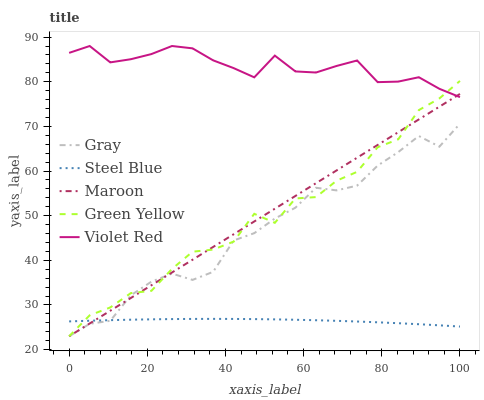Does Steel Blue have the minimum area under the curve?
Answer yes or no. Yes. Does Violet Red have the maximum area under the curve?
Answer yes or no. Yes. Does Green Yellow have the minimum area under the curve?
Answer yes or no. No. Does Green Yellow have the maximum area under the curve?
Answer yes or no. No. Is Maroon the smoothest?
Answer yes or no. Yes. Is Green Yellow the roughest?
Answer yes or no. Yes. Is Violet Red the smoothest?
Answer yes or no. No. Is Violet Red the roughest?
Answer yes or no. No. Does Violet Red have the lowest value?
Answer yes or no. No. Does Violet Red have the highest value?
Answer yes or no. Yes. Does Green Yellow have the highest value?
Answer yes or no. No. Is Gray less than Violet Red?
Answer yes or no. Yes. Is Violet Red greater than Gray?
Answer yes or no. Yes. Does Maroon intersect Violet Red?
Answer yes or no. Yes. Is Maroon less than Violet Red?
Answer yes or no. No. Is Maroon greater than Violet Red?
Answer yes or no. No. Does Gray intersect Violet Red?
Answer yes or no. No. 